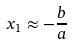<formula> <loc_0><loc_0><loc_500><loc_500>x _ { 1 } \approx - \frac { b } { a }</formula> 